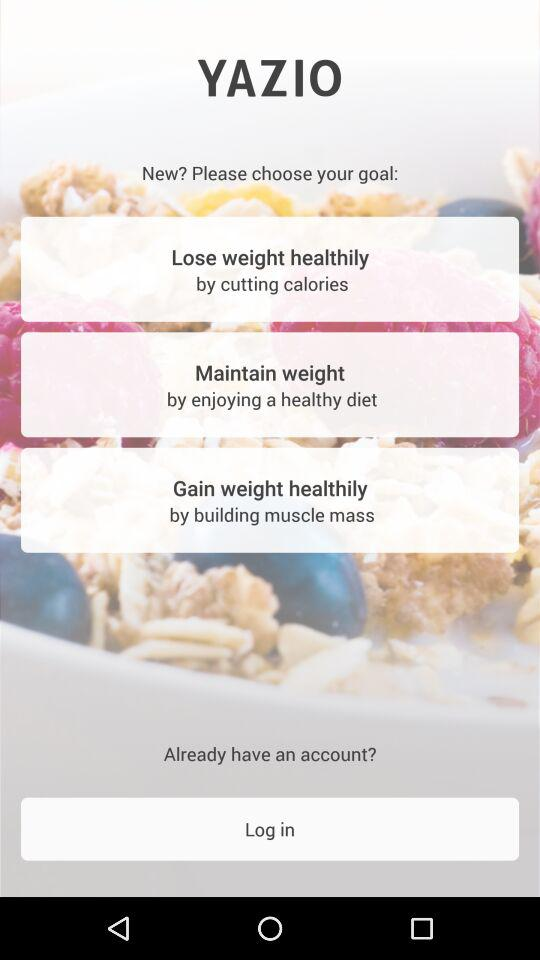How many goals are there to choose from?
Answer the question using a single word or phrase. 3 